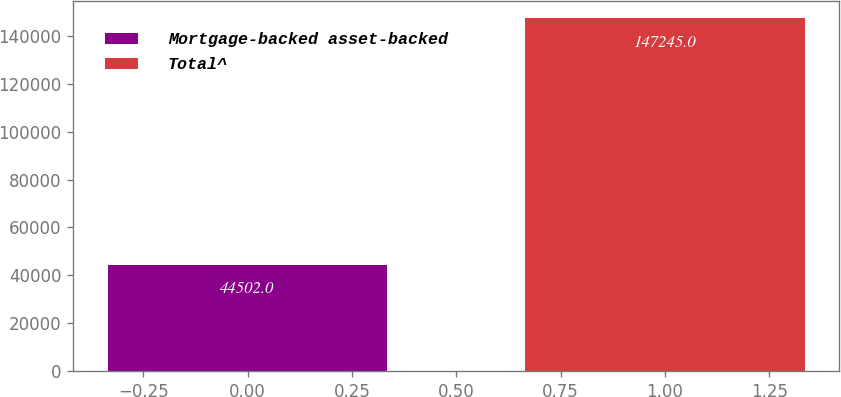Convert chart to OTSL. <chart><loc_0><loc_0><loc_500><loc_500><bar_chart><fcel>Mortgage-backed asset-backed<fcel>Total^<nl><fcel>44502<fcel>147245<nl></chart> 